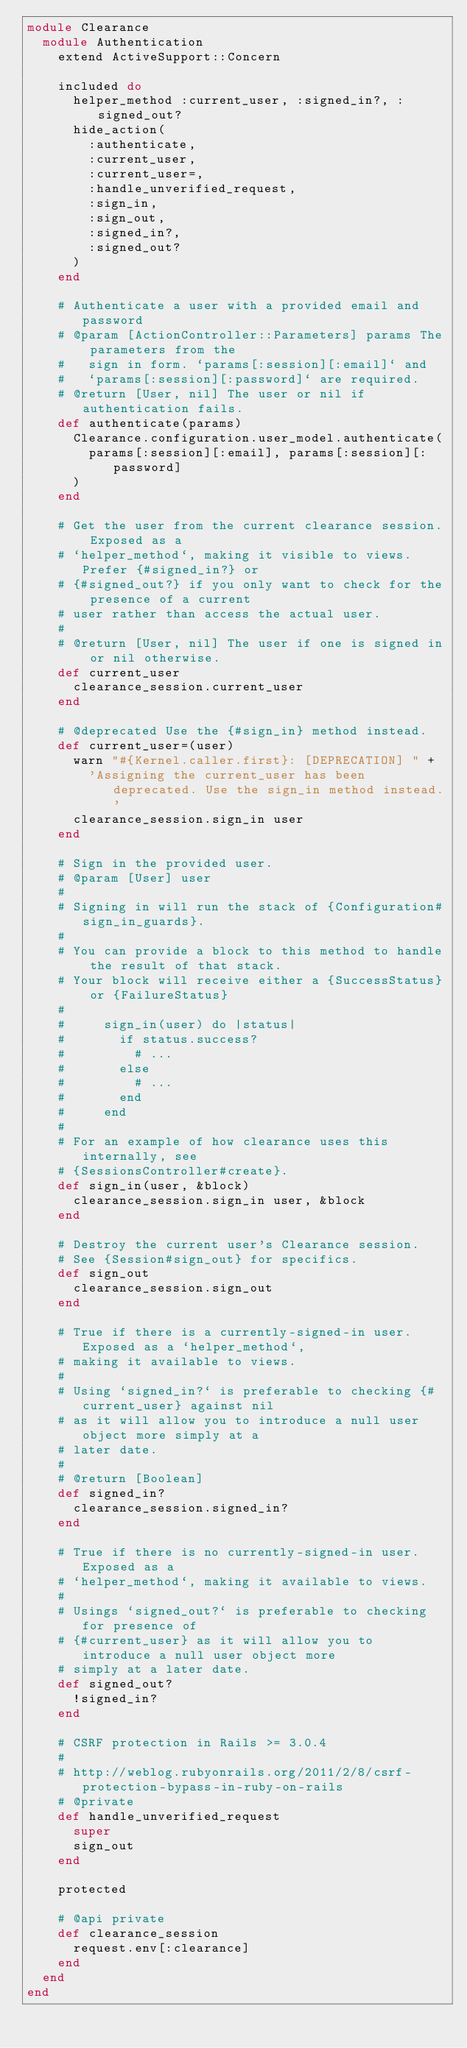<code> <loc_0><loc_0><loc_500><loc_500><_Ruby_>module Clearance
  module Authentication
    extend ActiveSupport::Concern

    included do
      helper_method :current_user, :signed_in?, :signed_out?
      hide_action(
        :authenticate,
        :current_user,
        :current_user=,
        :handle_unverified_request,
        :sign_in,
        :sign_out,
        :signed_in?,
        :signed_out?
      )
    end

    # Authenticate a user with a provided email and password
    # @param [ActionController::Parameters] params The parameters from the
    #   sign in form. `params[:session][:email]` and
    #   `params[:session][:password]` are required.
    # @return [User, nil] The user or nil if authentication fails.
    def authenticate(params)
      Clearance.configuration.user_model.authenticate(
        params[:session][:email], params[:session][:password]
      )
    end

    # Get the user from the current clearance session. Exposed as a
    # `helper_method`, making it visible to views. Prefer {#signed_in?} or
    # {#signed_out?} if you only want to check for the presence of a current
    # user rather than access the actual user.
    #
    # @return [User, nil] The user if one is signed in or nil otherwise.
    def current_user
      clearance_session.current_user
    end

    # @deprecated Use the {#sign_in} method instead.
    def current_user=(user)
      warn "#{Kernel.caller.first}: [DEPRECATION] " +
        'Assigning the current_user has been deprecated. Use the sign_in method instead.'
      clearance_session.sign_in user
    end

    # Sign in the provided user.
    # @param [User] user
    #
    # Signing in will run the stack of {Configuration#sign_in_guards}.
    #
    # You can provide a block to this method to handle the result of that stack.
    # Your block will receive either a {SuccessStatus} or {FailureStatus}
    #
    #     sign_in(user) do |status|
    #       if status.success?
    #         # ...
    #       else
    #         # ...
    #       end
    #     end
    #
    # For an example of how clearance uses this internally, see
    # {SessionsController#create}.
    def sign_in(user, &block)
      clearance_session.sign_in user, &block
    end

    # Destroy the current user's Clearance session.
    # See {Session#sign_out} for specifics.
    def sign_out
      clearance_session.sign_out
    end

    # True if there is a currently-signed-in user. Exposed as a `helper_method`,
    # making it available to views.
    #
    # Using `signed_in?` is preferable to checking {#current_user} against nil
    # as it will allow you to introduce a null user object more simply at a
    # later date.
    #
    # @return [Boolean]
    def signed_in?
      clearance_session.signed_in?
    end

    # True if there is no currently-signed-in user. Exposed as a
    # `helper_method`, making it available to views.
    #
    # Usings `signed_out?` is preferable to checking for presence of
    # {#current_user} as it will allow you to introduce a null user object more
    # simply at a later date.
    def signed_out?
      !signed_in?
    end

    # CSRF protection in Rails >= 3.0.4
    #
    # http://weblog.rubyonrails.org/2011/2/8/csrf-protection-bypass-in-ruby-on-rails
    # @private
    def handle_unverified_request
      super
      sign_out
    end

    protected

    # @api private
    def clearance_session
      request.env[:clearance]
    end
  end
end
</code> 